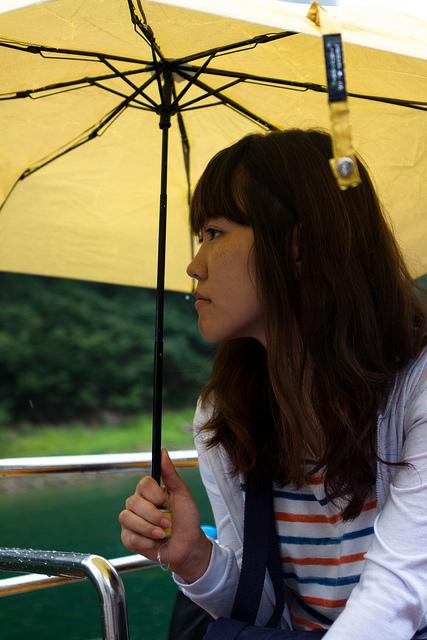What does this person use the umbrella for? Please explain your reasoning. rain. This person is using the umbrella to protect against the rain. 